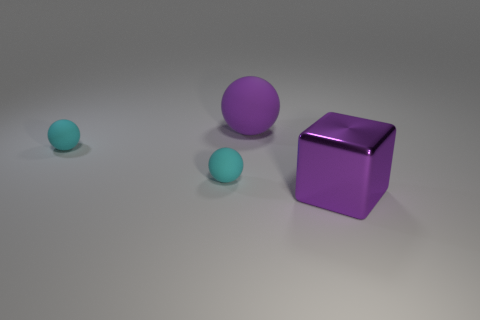Are there any other things that are the same material as the big purple cube?
Provide a short and direct response. No. What number of cyan rubber objects have the same shape as the big purple rubber thing?
Give a very brief answer. 2. Is the shape of the purple matte object the same as the big metallic thing?
Ensure brevity in your answer.  No. How many things are objects that are to the left of the large metal thing or purple rubber balls?
Your response must be concise. 3. The purple object on the left side of the large object on the right side of the big rubber sphere behind the purple metallic object is what shape?
Your response must be concise. Sphere. The purple matte object has what size?
Your answer should be very brief. Large. Does the purple ball have the same size as the metal thing?
Provide a short and direct response. Yes. How many objects are big purple things behind the purple shiny thing or purple objects behind the large cube?
Your answer should be compact. 1. There is a thing to the right of the purple thing that is behind the metal thing; how many big purple spheres are to the right of it?
Offer a very short reply. 0. How big is the purple thing that is to the left of the metal object?
Offer a terse response. Large. 